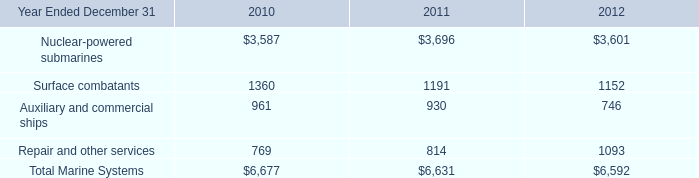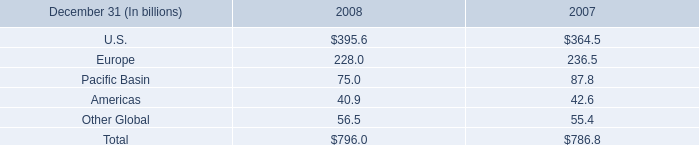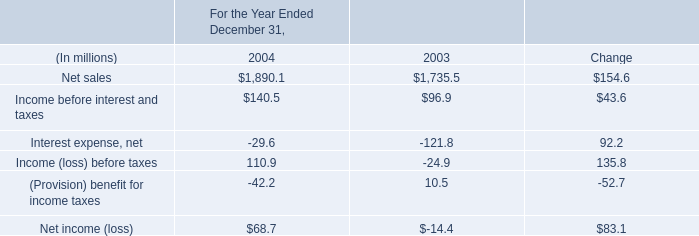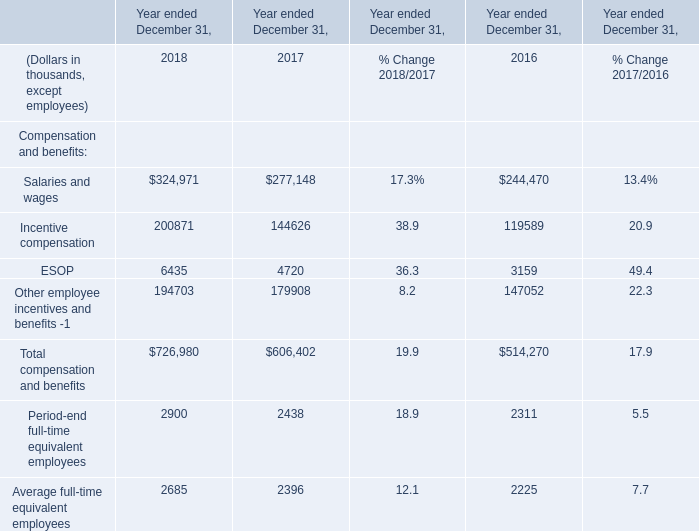what was the change in total corrugated products volume sold in billion square feet from 2004 compared to 2003? 
Computations: (29.9 - 28.1)
Answer: 1.8. 